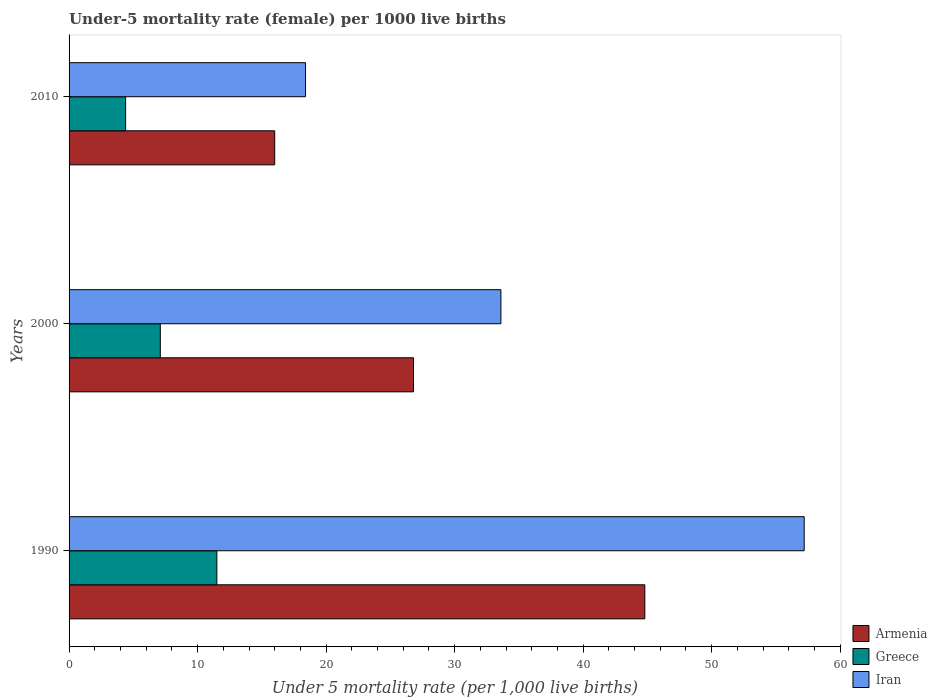How many different coloured bars are there?
Keep it short and to the point. 3. Are the number of bars per tick equal to the number of legend labels?
Offer a terse response. Yes. How many bars are there on the 1st tick from the top?
Ensure brevity in your answer.  3. How many bars are there on the 1st tick from the bottom?
Your answer should be very brief. 3. What is the label of the 1st group of bars from the top?
Your answer should be very brief. 2010. Across all years, what is the minimum under-five mortality rate in Armenia?
Provide a short and direct response. 16. What is the total under-five mortality rate in Iran in the graph?
Your answer should be compact. 109.2. What is the difference between the under-five mortality rate in Greece in 1990 and that in 2010?
Make the answer very short. 7.1. What is the difference between the under-five mortality rate in Iran in 1990 and the under-five mortality rate in Greece in 2010?
Ensure brevity in your answer.  52.8. What is the average under-five mortality rate in Armenia per year?
Give a very brief answer. 29.2. In the year 1990, what is the difference between the under-five mortality rate in Iran and under-five mortality rate in Greece?
Ensure brevity in your answer.  45.7. What is the ratio of the under-five mortality rate in Greece in 1990 to that in 2010?
Offer a very short reply. 2.61. Is the under-five mortality rate in Iran in 1990 less than that in 2000?
Offer a very short reply. No. What is the difference between the highest and the second highest under-five mortality rate in Iran?
Offer a very short reply. 23.6. What is the difference between the highest and the lowest under-five mortality rate in Armenia?
Keep it short and to the point. 28.8. What does the 3rd bar from the bottom in 2010 represents?
Your answer should be compact. Iran. Is it the case that in every year, the sum of the under-five mortality rate in Iran and under-five mortality rate in Greece is greater than the under-five mortality rate in Armenia?
Your response must be concise. Yes. How many bars are there?
Make the answer very short. 9. Are all the bars in the graph horizontal?
Your response must be concise. Yes. Does the graph contain grids?
Offer a terse response. No. Where does the legend appear in the graph?
Your answer should be very brief. Bottom right. What is the title of the graph?
Your response must be concise. Under-5 mortality rate (female) per 1000 live births. What is the label or title of the X-axis?
Make the answer very short. Under 5 mortality rate (per 1,0 live births). What is the label or title of the Y-axis?
Your answer should be compact. Years. What is the Under 5 mortality rate (per 1,000 live births) in Armenia in 1990?
Your answer should be very brief. 44.8. What is the Under 5 mortality rate (per 1,000 live births) of Iran in 1990?
Ensure brevity in your answer.  57.2. What is the Under 5 mortality rate (per 1,000 live births) in Armenia in 2000?
Provide a short and direct response. 26.8. What is the Under 5 mortality rate (per 1,000 live births) of Greece in 2000?
Your answer should be compact. 7.1. What is the Under 5 mortality rate (per 1,000 live births) in Iran in 2000?
Make the answer very short. 33.6. What is the Under 5 mortality rate (per 1,000 live births) in Iran in 2010?
Ensure brevity in your answer.  18.4. Across all years, what is the maximum Under 5 mortality rate (per 1,000 live births) of Armenia?
Make the answer very short. 44.8. Across all years, what is the maximum Under 5 mortality rate (per 1,000 live births) in Iran?
Keep it short and to the point. 57.2. Across all years, what is the minimum Under 5 mortality rate (per 1,000 live births) in Iran?
Make the answer very short. 18.4. What is the total Under 5 mortality rate (per 1,000 live births) in Armenia in the graph?
Offer a terse response. 87.6. What is the total Under 5 mortality rate (per 1,000 live births) in Greece in the graph?
Your answer should be very brief. 23. What is the total Under 5 mortality rate (per 1,000 live births) in Iran in the graph?
Keep it short and to the point. 109.2. What is the difference between the Under 5 mortality rate (per 1,000 live births) of Greece in 1990 and that in 2000?
Provide a short and direct response. 4.4. What is the difference between the Under 5 mortality rate (per 1,000 live births) of Iran in 1990 and that in 2000?
Offer a terse response. 23.6. What is the difference between the Under 5 mortality rate (per 1,000 live births) of Armenia in 1990 and that in 2010?
Provide a succinct answer. 28.8. What is the difference between the Under 5 mortality rate (per 1,000 live births) in Iran in 1990 and that in 2010?
Give a very brief answer. 38.8. What is the difference between the Under 5 mortality rate (per 1,000 live births) in Armenia in 2000 and that in 2010?
Your response must be concise. 10.8. What is the difference between the Under 5 mortality rate (per 1,000 live births) in Greece in 2000 and that in 2010?
Offer a terse response. 2.7. What is the difference between the Under 5 mortality rate (per 1,000 live births) of Iran in 2000 and that in 2010?
Keep it short and to the point. 15.2. What is the difference between the Under 5 mortality rate (per 1,000 live births) of Armenia in 1990 and the Under 5 mortality rate (per 1,000 live births) of Greece in 2000?
Provide a short and direct response. 37.7. What is the difference between the Under 5 mortality rate (per 1,000 live births) of Greece in 1990 and the Under 5 mortality rate (per 1,000 live births) of Iran in 2000?
Provide a succinct answer. -22.1. What is the difference between the Under 5 mortality rate (per 1,000 live births) in Armenia in 1990 and the Under 5 mortality rate (per 1,000 live births) in Greece in 2010?
Ensure brevity in your answer.  40.4. What is the difference between the Under 5 mortality rate (per 1,000 live births) of Armenia in 1990 and the Under 5 mortality rate (per 1,000 live births) of Iran in 2010?
Keep it short and to the point. 26.4. What is the difference between the Under 5 mortality rate (per 1,000 live births) of Armenia in 2000 and the Under 5 mortality rate (per 1,000 live births) of Greece in 2010?
Give a very brief answer. 22.4. What is the average Under 5 mortality rate (per 1,000 live births) in Armenia per year?
Your answer should be compact. 29.2. What is the average Under 5 mortality rate (per 1,000 live births) in Greece per year?
Give a very brief answer. 7.67. What is the average Under 5 mortality rate (per 1,000 live births) of Iran per year?
Provide a succinct answer. 36.4. In the year 1990, what is the difference between the Under 5 mortality rate (per 1,000 live births) of Armenia and Under 5 mortality rate (per 1,000 live births) of Greece?
Ensure brevity in your answer.  33.3. In the year 1990, what is the difference between the Under 5 mortality rate (per 1,000 live births) of Greece and Under 5 mortality rate (per 1,000 live births) of Iran?
Make the answer very short. -45.7. In the year 2000, what is the difference between the Under 5 mortality rate (per 1,000 live births) of Greece and Under 5 mortality rate (per 1,000 live births) of Iran?
Make the answer very short. -26.5. In the year 2010, what is the difference between the Under 5 mortality rate (per 1,000 live births) in Greece and Under 5 mortality rate (per 1,000 live births) in Iran?
Provide a succinct answer. -14. What is the ratio of the Under 5 mortality rate (per 1,000 live births) in Armenia in 1990 to that in 2000?
Your response must be concise. 1.67. What is the ratio of the Under 5 mortality rate (per 1,000 live births) in Greece in 1990 to that in 2000?
Offer a terse response. 1.62. What is the ratio of the Under 5 mortality rate (per 1,000 live births) of Iran in 1990 to that in 2000?
Your answer should be very brief. 1.7. What is the ratio of the Under 5 mortality rate (per 1,000 live births) in Armenia in 1990 to that in 2010?
Provide a succinct answer. 2.8. What is the ratio of the Under 5 mortality rate (per 1,000 live births) in Greece in 1990 to that in 2010?
Provide a short and direct response. 2.61. What is the ratio of the Under 5 mortality rate (per 1,000 live births) of Iran in 1990 to that in 2010?
Provide a short and direct response. 3.11. What is the ratio of the Under 5 mortality rate (per 1,000 live births) of Armenia in 2000 to that in 2010?
Give a very brief answer. 1.68. What is the ratio of the Under 5 mortality rate (per 1,000 live births) of Greece in 2000 to that in 2010?
Provide a short and direct response. 1.61. What is the ratio of the Under 5 mortality rate (per 1,000 live births) of Iran in 2000 to that in 2010?
Your response must be concise. 1.83. What is the difference between the highest and the second highest Under 5 mortality rate (per 1,000 live births) in Armenia?
Ensure brevity in your answer.  18. What is the difference between the highest and the second highest Under 5 mortality rate (per 1,000 live births) of Iran?
Keep it short and to the point. 23.6. What is the difference between the highest and the lowest Under 5 mortality rate (per 1,000 live births) of Armenia?
Give a very brief answer. 28.8. What is the difference between the highest and the lowest Under 5 mortality rate (per 1,000 live births) in Greece?
Offer a terse response. 7.1. What is the difference between the highest and the lowest Under 5 mortality rate (per 1,000 live births) of Iran?
Your answer should be very brief. 38.8. 